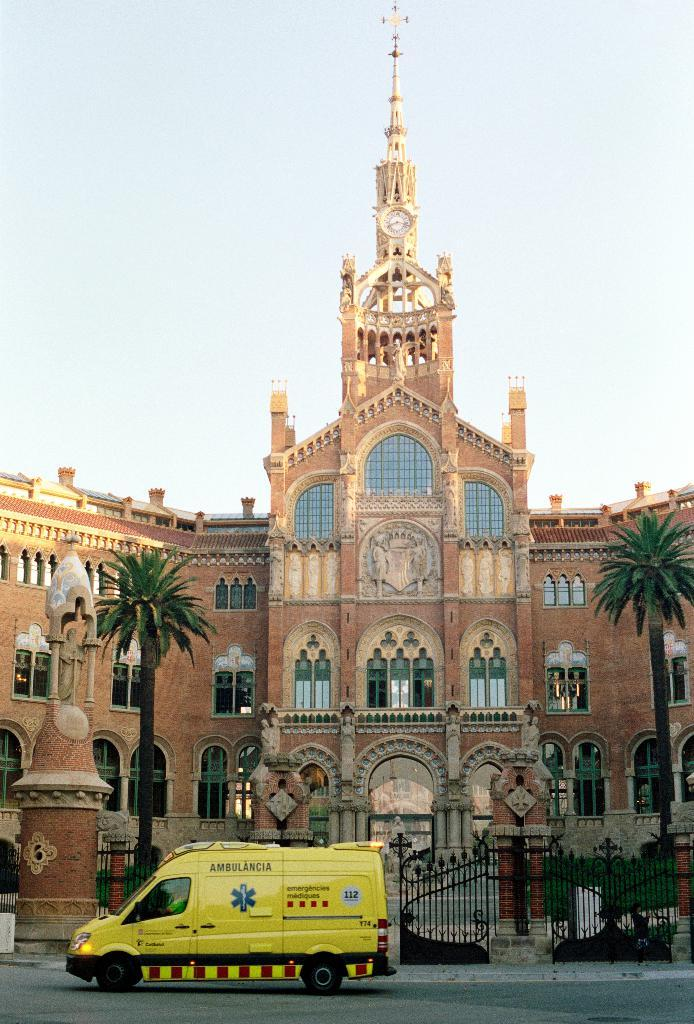What type of structure is visible in the image? There is a building in the image. What natural elements are present near the building? The building has two trees. What is the entrance to the building like? There is a gate in front of the building. What else can be seen in front of the building? A vehicle is present in front of the building. What type of stage is set up in front of the building? There is no stage present in the image; it only shows a building, trees, a gate, and a vehicle. 